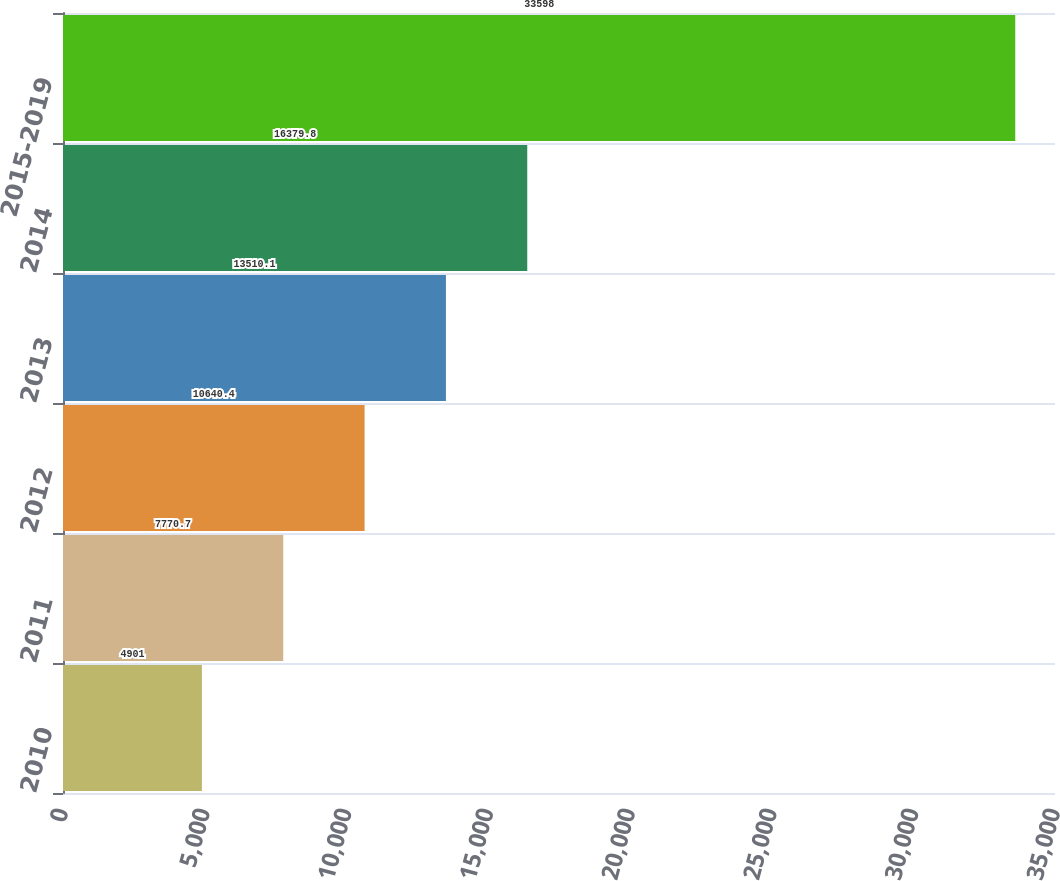Convert chart to OTSL. <chart><loc_0><loc_0><loc_500><loc_500><bar_chart><fcel>2010<fcel>2011<fcel>2012<fcel>2013<fcel>2014<fcel>2015-2019<nl><fcel>4901<fcel>7770.7<fcel>10640.4<fcel>13510.1<fcel>16379.8<fcel>33598<nl></chart> 